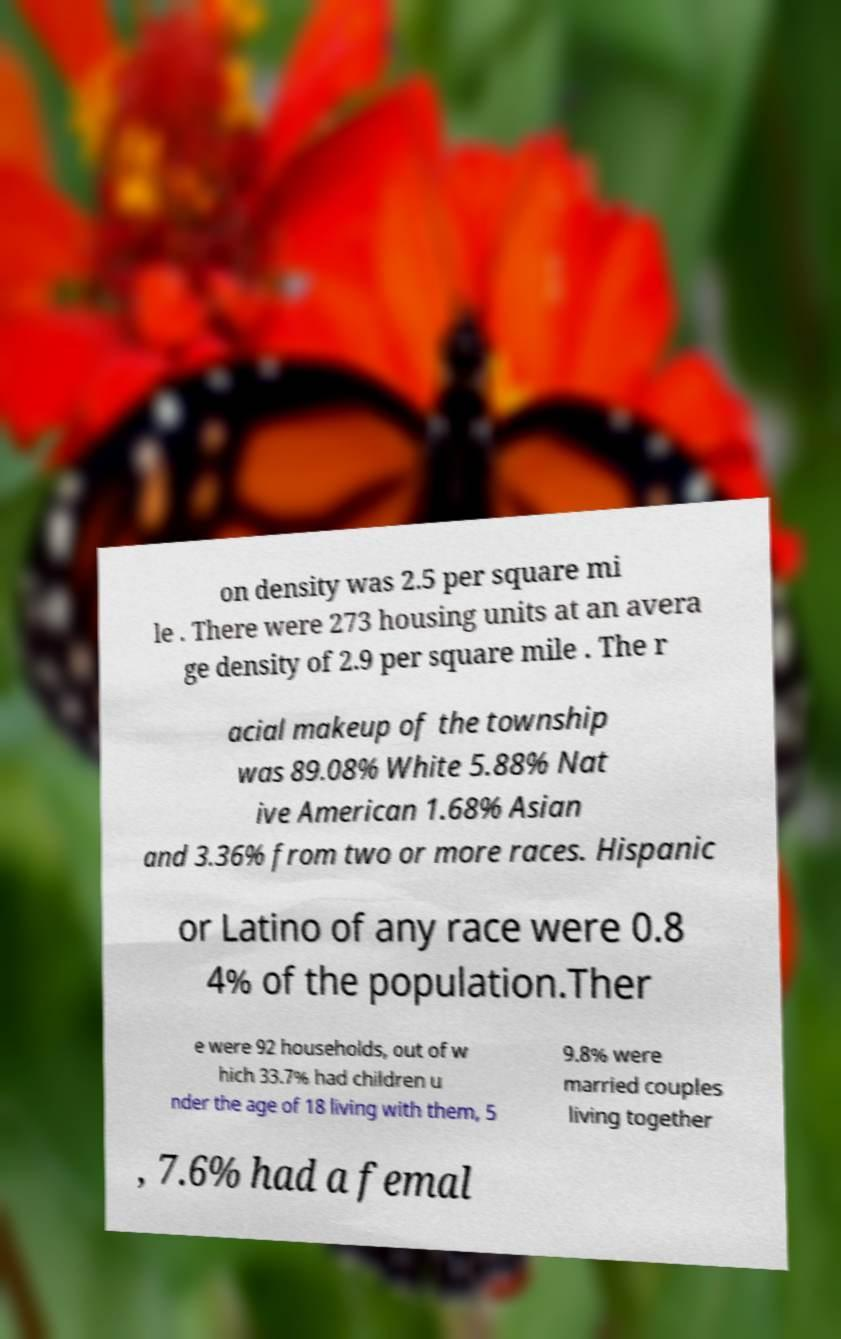For documentation purposes, I need the text within this image transcribed. Could you provide that? on density was 2.5 per square mi le . There were 273 housing units at an avera ge density of 2.9 per square mile . The r acial makeup of the township was 89.08% White 5.88% Nat ive American 1.68% Asian and 3.36% from two or more races. Hispanic or Latino of any race were 0.8 4% of the population.Ther e were 92 households, out of w hich 33.7% had children u nder the age of 18 living with them, 5 9.8% were married couples living together , 7.6% had a femal 